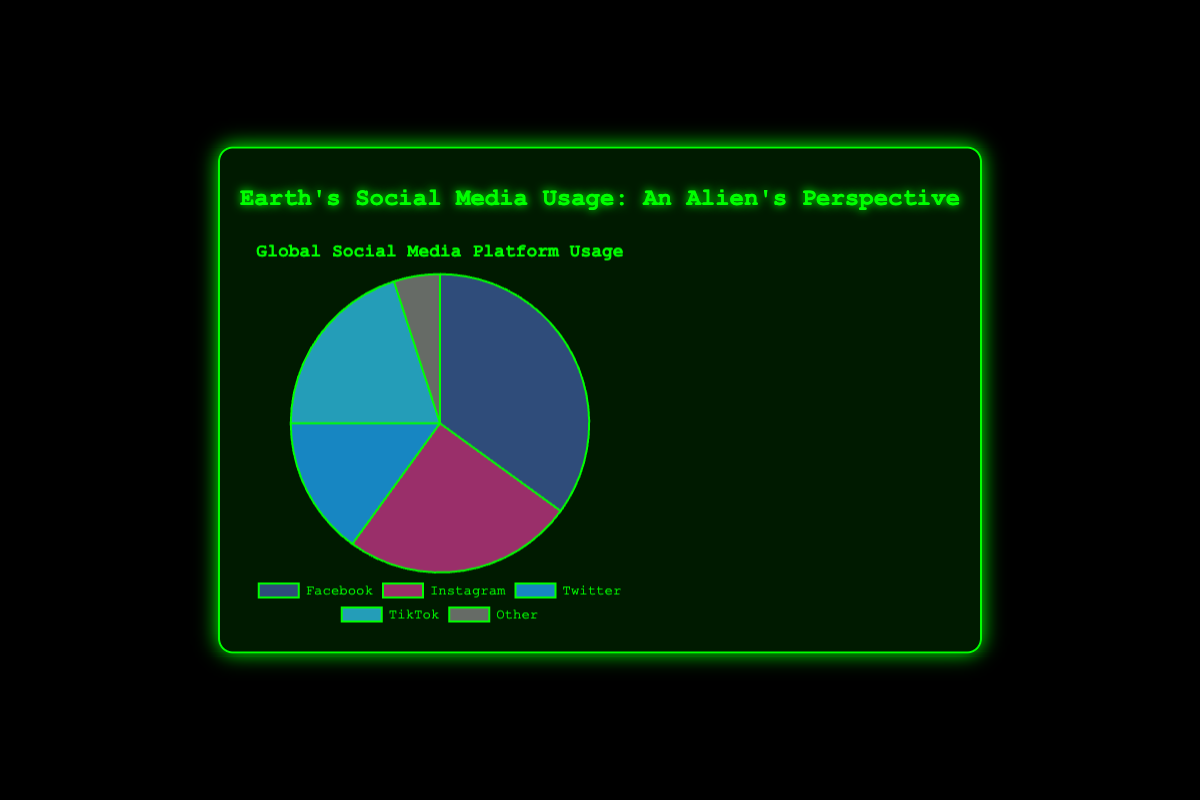What is the most popular social media platform according to the pie chart? The most popular platform is the one with the largest slice. By looking at the chart, Facebook has the largest slice representing 35% of the total usage.
Answer: Facebook Which two platforms combined make up less than half of the social media usage? We need to identify two platforms whose combined usage is less than 50%. Instagram (25%) and Twitter (15%) together make 40%, which is less than 50%.
Answer: Instagram and Twitter What percentage of total usage do the least and most popular platforms account for together? The least popular platform is "Other" with 5%, and the most popular is Facebook with 35%. Adding them gives a total of 40%.
Answer: 40% How much more popular is TikTok compared to Twitter? We need to subtract the percentage of Twitter from TikTok. TikTok is 20% and Twitter is 15%, thus TikTok is 5% more popular.
Answer: 5% If the total number of social media users is 1,000,000, how many users are there for Instagram? Instagram makes up 25% of the total usage. To find the number of users, we calculate 25% of 1,000,000 which is 250,000 users.
Answer: 250,000 Rank the social media platforms from most to least popular visually based on the size of the slices in the pie chart. By comparing the sizes of the slices, the ranking from most to least popular is Facebook, Instagram, TikTok, Twitter, Other.
Answer: Facebook, Instagram, TikTok, Twitter, Other What is the combined percentage usage of platforms other than Facebook and Instagram? Adding the percentages, TikTok (20%) + Twitter (15%) + Other (5%) = 40%.
Answer: 40% How does the usage of TikTok compare to the combined usage of Twitter and Other? TikTok's usage is 20%. The combined usage of Twitter (15%) and Other (5%) is also 20%, making them equal.
Answer: Equal What percentage of the total usage do the platforms with less than 20% use account for? Platforms with less than 20% usage are Twitter (15%) and Other (5%), which combined is 20%.
Answer: 20% Is the percentage usage of Instagram closer to that of Facebook or TikTok? Instagram is at 25%. Comparing the differences: Facebook (35%-25% = 10%), TikTok (25%-20% = 5%). The difference is smaller with TikTok, so Instagram's usage is closer to TikTok.
Answer: TikTok 